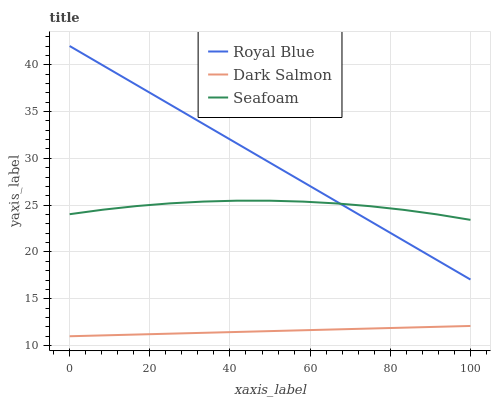Does Dark Salmon have the minimum area under the curve?
Answer yes or no. Yes. Does Royal Blue have the maximum area under the curve?
Answer yes or no. Yes. Does Seafoam have the minimum area under the curve?
Answer yes or no. No. Does Seafoam have the maximum area under the curve?
Answer yes or no. No. Is Dark Salmon the smoothest?
Answer yes or no. Yes. Is Seafoam the roughest?
Answer yes or no. Yes. Is Seafoam the smoothest?
Answer yes or no. No. Is Dark Salmon the roughest?
Answer yes or no. No. Does Dark Salmon have the lowest value?
Answer yes or no. Yes. Does Seafoam have the lowest value?
Answer yes or no. No. Does Royal Blue have the highest value?
Answer yes or no. Yes. Does Seafoam have the highest value?
Answer yes or no. No. Is Dark Salmon less than Royal Blue?
Answer yes or no. Yes. Is Seafoam greater than Dark Salmon?
Answer yes or no. Yes. Does Seafoam intersect Royal Blue?
Answer yes or no. Yes. Is Seafoam less than Royal Blue?
Answer yes or no. No. Is Seafoam greater than Royal Blue?
Answer yes or no. No. Does Dark Salmon intersect Royal Blue?
Answer yes or no. No. 